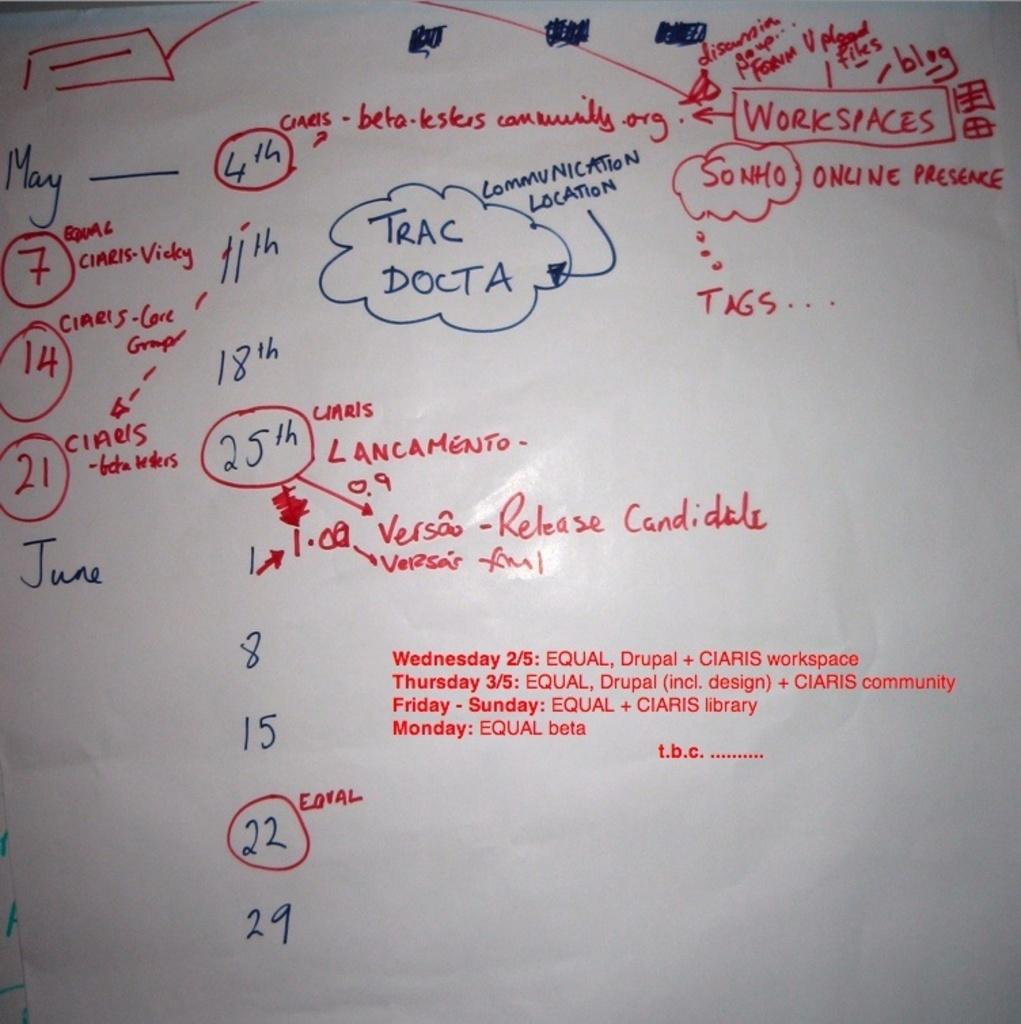Provide a one-sentence caption for the provided image. a whiteboard has a map starting with workspaces is at the right top corner. 